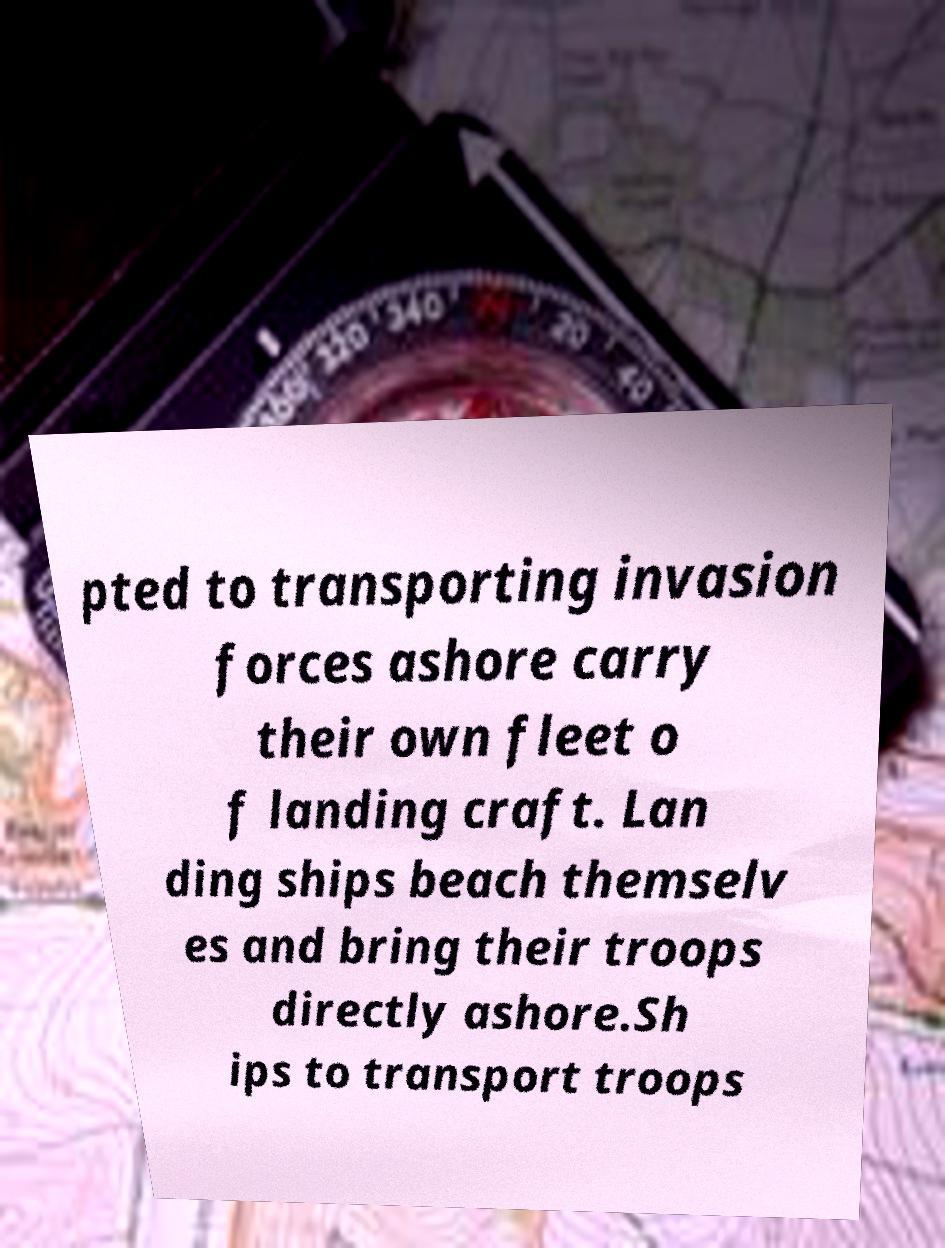Please read and relay the text visible in this image. What does it say? pted to transporting invasion forces ashore carry their own fleet o f landing craft. Lan ding ships beach themselv es and bring their troops directly ashore.Sh ips to transport troops 